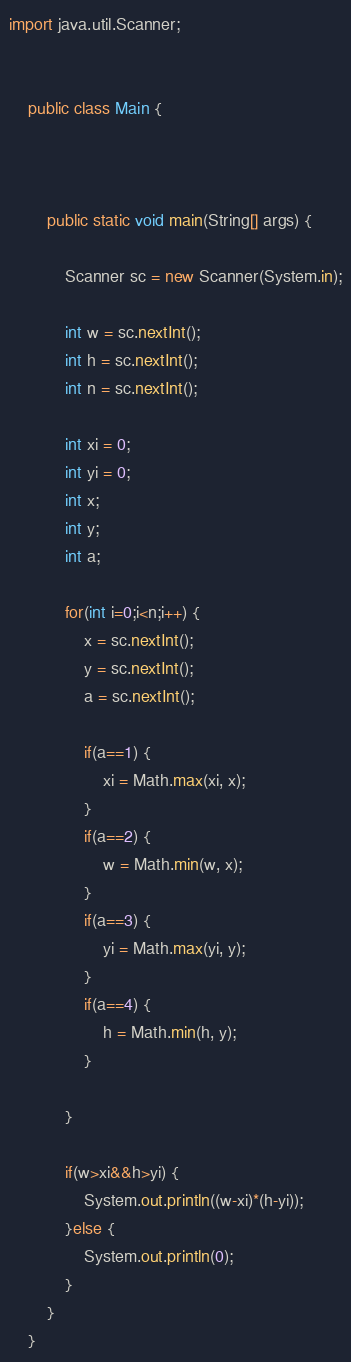Convert code to text. <code><loc_0><loc_0><loc_500><loc_500><_Java_>import java.util.Scanner;


	public class Main {
		
		

		public static void main(String[] args) {

			Scanner sc = new Scanner(System.in);
	        
			int w = sc.nextInt();
			int h = sc.nextInt();
			int n = sc.nextInt();
			
			int xi = 0;
			int yi = 0;
			int x;
			int y;
			int a;
			
			for(int i=0;i<n;i++) {
				x = sc.nextInt();
				y = sc.nextInt();
				a = sc.nextInt();
				
				if(a==1) {
					xi = Math.max(xi, x);
				}
				if(a==2) {
					w = Math.min(w, x);
				}
				if(a==3) {
					yi = Math.max(yi, y);
				}
				if(a==4) {
					h = Math.min(h, y);
				}
				
			}
			
			if(w>xi&&h>yi) {
				System.out.println((w-xi)*(h-yi));
			}else {
				System.out.println(0);
			}
		}
	}
</code> 